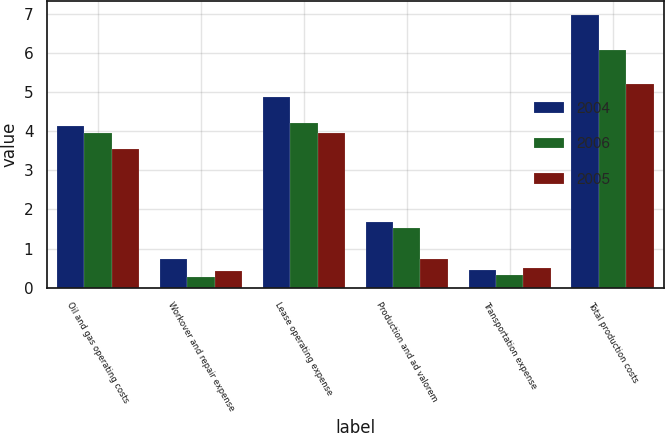<chart> <loc_0><loc_0><loc_500><loc_500><stacked_bar_chart><ecel><fcel>Oil and gas operating costs<fcel>Workover and repair expense<fcel>Lease operating expense<fcel>Production and ad valorem<fcel>Transportation expense<fcel>Total production costs<nl><fcel>2004<fcel>4.14<fcel>0.72<fcel>4.86<fcel>1.67<fcel>0.44<fcel>6.97<nl><fcel>2006<fcel>3.94<fcel>0.27<fcel>4.21<fcel>1.52<fcel>0.33<fcel>6.06<nl><fcel>2005<fcel>3.53<fcel>0.43<fcel>3.96<fcel>0.73<fcel>0.51<fcel>5.2<nl></chart> 